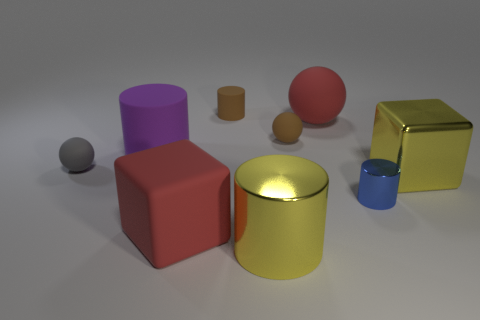There is a tiny gray object that is made of the same material as the purple object; what is its shape? sphere 